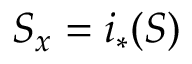Convert formula to latex. <formula><loc_0><loc_0><loc_500><loc_500>S _ { x } = i _ { * } ( S )</formula> 